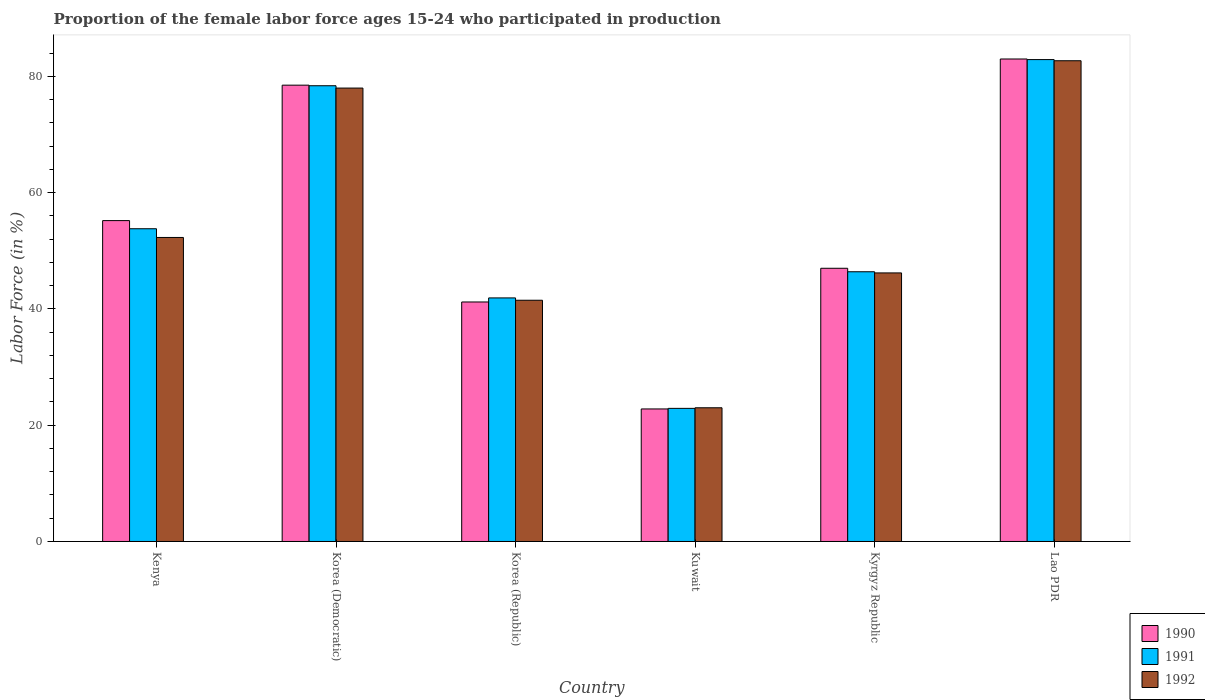How many groups of bars are there?
Keep it short and to the point. 6. How many bars are there on the 2nd tick from the left?
Your response must be concise. 3. How many bars are there on the 3rd tick from the right?
Offer a terse response. 3. What is the label of the 5th group of bars from the left?
Offer a very short reply. Kyrgyz Republic. What is the proportion of the female labor force who participated in production in 1991 in Kyrgyz Republic?
Provide a short and direct response. 46.4. Across all countries, what is the maximum proportion of the female labor force who participated in production in 1991?
Ensure brevity in your answer.  82.9. Across all countries, what is the minimum proportion of the female labor force who participated in production in 1990?
Your response must be concise. 22.8. In which country was the proportion of the female labor force who participated in production in 1991 maximum?
Offer a very short reply. Lao PDR. In which country was the proportion of the female labor force who participated in production in 1990 minimum?
Your answer should be very brief. Kuwait. What is the total proportion of the female labor force who participated in production in 1990 in the graph?
Provide a short and direct response. 327.7. What is the difference between the proportion of the female labor force who participated in production in 1992 in Kenya and that in Kyrgyz Republic?
Ensure brevity in your answer.  6.1. What is the difference between the proportion of the female labor force who participated in production in 1992 in Kyrgyz Republic and the proportion of the female labor force who participated in production in 1990 in Kuwait?
Keep it short and to the point. 23.4. What is the average proportion of the female labor force who participated in production in 1992 per country?
Your answer should be compact. 53.95. What is the difference between the proportion of the female labor force who participated in production of/in 1992 and proportion of the female labor force who participated in production of/in 1990 in Korea (Republic)?
Provide a short and direct response. 0.3. What is the ratio of the proportion of the female labor force who participated in production in 1991 in Kuwait to that in Lao PDR?
Offer a very short reply. 0.28. Is the proportion of the female labor force who participated in production in 1991 in Kenya less than that in Kuwait?
Your response must be concise. No. What is the difference between the highest and the second highest proportion of the female labor force who participated in production in 1992?
Ensure brevity in your answer.  30.4. What is the difference between the highest and the lowest proportion of the female labor force who participated in production in 1991?
Your answer should be compact. 60. Is the sum of the proportion of the female labor force who participated in production in 1992 in Korea (Republic) and Kuwait greater than the maximum proportion of the female labor force who participated in production in 1991 across all countries?
Your answer should be compact. No. What does the 1st bar from the left in Kenya represents?
Give a very brief answer. 1990. Is it the case that in every country, the sum of the proportion of the female labor force who participated in production in 1992 and proportion of the female labor force who participated in production in 1990 is greater than the proportion of the female labor force who participated in production in 1991?
Give a very brief answer. Yes. Does the graph contain any zero values?
Provide a short and direct response. No. Does the graph contain grids?
Offer a very short reply. No. Where does the legend appear in the graph?
Offer a terse response. Bottom right. What is the title of the graph?
Keep it short and to the point. Proportion of the female labor force ages 15-24 who participated in production. What is the label or title of the X-axis?
Make the answer very short. Country. What is the label or title of the Y-axis?
Ensure brevity in your answer.  Labor Force (in %). What is the Labor Force (in %) in 1990 in Kenya?
Your response must be concise. 55.2. What is the Labor Force (in %) in 1991 in Kenya?
Your answer should be very brief. 53.8. What is the Labor Force (in %) in 1992 in Kenya?
Your answer should be very brief. 52.3. What is the Labor Force (in %) in 1990 in Korea (Democratic)?
Your response must be concise. 78.5. What is the Labor Force (in %) in 1991 in Korea (Democratic)?
Offer a very short reply. 78.4. What is the Labor Force (in %) in 1992 in Korea (Democratic)?
Make the answer very short. 78. What is the Labor Force (in %) in 1990 in Korea (Republic)?
Give a very brief answer. 41.2. What is the Labor Force (in %) of 1991 in Korea (Republic)?
Offer a very short reply. 41.9. What is the Labor Force (in %) in 1992 in Korea (Republic)?
Ensure brevity in your answer.  41.5. What is the Labor Force (in %) in 1990 in Kuwait?
Give a very brief answer. 22.8. What is the Labor Force (in %) in 1991 in Kuwait?
Ensure brevity in your answer.  22.9. What is the Labor Force (in %) in 1990 in Kyrgyz Republic?
Your answer should be compact. 47. What is the Labor Force (in %) of 1991 in Kyrgyz Republic?
Provide a succinct answer. 46.4. What is the Labor Force (in %) in 1992 in Kyrgyz Republic?
Ensure brevity in your answer.  46.2. What is the Labor Force (in %) in 1991 in Lao PDR?
Your answer should be compact. 82.9. What is the Labor Force (in %) of 1992 in Lao PDR?
Offer a very short reply. 82.7. Across all countries, what is the maximum Labor Force (in %) of 1991?
Ensure brevity in your answer.  82.9. Across all countries, what is the maximum Labor Force (in %) in 1992?
Make the answer very short. 82.7. Across all countries, what is the minimum Labor Force (in %) in 1990?
Give a very brief answer. 22.8. Across all countries, what is the minimum Labor Force (in %) of 1991?
Ensure brevity in your answer.  22.9. Across all countries, what is the minimum Labor Force (in %) in 1992?
Keep it short and to the point. 23. What is the total Labor Force (in %) of 1990 in the graph?
Offer a very short reply. 327.7. What is the total Labor Force (in %) in 1991 in the graph?
Your answer should be compact. 326.3. What is the total Labor Force (in %) of 1992 in the graph?
Give a very brief answer. 323.7. What is the difference between the Labor Force (in %) of 1990 in Kenya and that in Korea (Democratic)?
Offer a terse response. -23.3. What is the difference between the Labor Force (in %) of 1991 in Kenya and that in Korea (Democratic)?
Provide a short and direct response. -24.6. What is the difference between the Labor Force (in %) in 1992 in Kenya and that in Korea (Democratic)?
Ensure brevity in your answer.  -25.7. What is the difference between the Labor Force (in %) of 1990 in Kenya and that in Korea (Republic)?
Your answer should be compact. 14. What is the difference between the Labor Force (in %) of 1991 in Kenya and that in Korea (Republic)?
Your answer should be very brief. 11.9. What is the difference between the Labor Force (in %) of 1992 in Kenya and that in Korea (Republic)?
Your answer should be compact. 10.8. What is the difference between the Labor Force (in %) of 1990 in Kenya and that in Kuwait?
Make the answer very short. 32.4. What is the difference between the Labor Force (in %) in 1991 in Kenya and that in Kuwait?
Give a very brief answer. 30.9. What is the difference between the Labor Force (in %) in 1992 in Kenya and that in Kuwait?
Your answer should be very brief. 29.3. What is the difference between the Labor Force (in %) of 1990 in Kenya and that in Kyrgyz Republic?
Give a very brief answer. 8.2. What is the difference between the Labor Force (in %) in 1991 in Kenya and that in Kyrgyz Republic?
Offer a very short reply. 7.4. What is the difference between the Labor Force (in %) of 1990 in Kenya and that in Lao PDR?
Keep it short and to the point. -27.8. What is the difference between the Labor Force (in %) in 1991 in Kenya and that in Lao PDR?
Offer a very short reply. -29.1. What is the difference between the Labor Force (in %) of 1992 in Kenya and that in Lao PDR?
Provide a short and direct response. -30.4. What is the difference between the Labor Force (in %) of 1990 in Korea (Democratic) and that in Korea (Republic)?
Offer a very short reply. 37.3. What is the difference between the Labor Force (in %) in 1991 in Korea (Democratic) and that in Korea (Republic)?
Keep it short and to the point. 36.5. What is the difference between the Labor Force (in %) of 1992 in Korea (Democratic) and that in Korea (Republic)?
Make the answer very short. 36.5. What is the difference between the Labor Force (in %) in 1990 in Korea (Democratic) and that in Kuwait?
Offer a terse response. 55.7. What is the difference between the Labor Force (in %) in 1991 in Korea (Democratic) and that in Kuwait?
Provide a short and direct response. 55.5. What is the difference between the Labor Force (in %) of 1990 in Korea (Democratic) and that in Kyrgyz Republic?
Keep it short and to the point. 31.5. What is the difference between the Labor Force (in %) of 1992 in Korea (Democratic) and that in Kyrgyz Republic?
Your response must be concise. 31.8. What is the difference between the Labor Force (in %) in 1990 in Korea (Republic) and that in Kuwait?
Your answer should be compact. 18.4. What is the difference between the Labor Force (in %) in 1992 in Korea (Republic) and that in Kuwait?
Your answer should be very brief. 18.5. What is the difference between the Labor Force (in %) in 1990 in Korea (Republic) and that in Kyrgyz Republic?
Give a very brief answer. -5.8. What is the difference between the Labor Force (in %) in 1991 in Korea (Republic) and that in Kyrgyz Republic?
Provide a short and direct response. -4.5. What is the difference between the Labor Force (in %) in 1990 in Korea (Republic) and that in Lao PDR?
Offer a very short reply. -41.8. What is the difference between the Labor Force (in %) of 1991 in Korea (Republic) and that in Lao PDR?
Your response must be concise. -41. What is the difference between the Labor Force (in %) of 1992 in Korea (Republic) and that in Lao PDR?
Offer a terse response. -41.2. What is the difference between the Labor Force (in %) of 1990 in Kuwait and that in Kyrgyz Republic?
Give a very brief answer. -24.2. What is the difference between the Labor Force (in %) of 1991 in Kuwait and that in Kyrgyz Republic?
Your response must be concise. -23.5. What is the difference between the Labor Force (in %) of 1992 in Kuwait and that in Kyrgyz Republic?
Give a very brief answer. -23.2. What is the difference between the Labor Force (in %) of 1990 in Kuwait and that in Lao PDR?
Your answer should be compact. -60.2. What is the difference between the Labor Force (in %) of 1991 in Kuwait and that in Lao PDR?
Offer a very short reply. -60. What is the difference between the Labor Force (in %) in 1992 in Kuwait and that in Lao PDR?
Give a very brief answer. -59.7. What is the difference between the Labor Force (in %) of 1990 in Kyrgyz Republic and that in Lao PDR?
Offer a very short reply. -36. What is the difference between the Labor Force (in %) of 1991 in Kyrgyz Republic and that in Lao PDR?
Keep it short and to the point. -36.5. What is the difference between the Labor Force (in %) of 1992 in Kyrgyz Republic and that in Lao PDR?
Offer a terse response. -36.5. What is the difference between the Labor Force (in %) of 1990 in Kenya and the Labor Force (in %) of 1991 in Korea (Democratic)?
Keep it short and to the point. -23.2. What is the difference between the Labor Force (in %) of 1990 in Kenya and the Labor Force (in %) of 1992 in Korea (Democratic)?
Keep it short and to the point. -22.8. What is the difference between the Labor Force (in %) of 1991 in Kenya and the Labor Force (in %) of 1992 in Korea (Democratic)?
Provide a short and direct response. -24.2. What is the difference between the Labor Force (in %) of 1990 in Kenya and the Labor Force (in %) of 1991 in Kuwait?
Your response must be concise. 32.3. What is the difference between the Labor Force (in %) in 1990 in Kenya and the Labor Force (in %) in 1992 in Kuwait?
Make the answer very short. 32.2. What is the difference between the Labor Force (in %) of 1991 in Kenya and the Labor Force (in %) of 1992 in Kuwait?
Offer a terse response. 30.8. What is the difference between the Labor Force (in %) in 1990 in Kenya and the Labor Force (in %) in 1991 in Kyrgyz Republic?
Make the answer very short. 8.8. What is the difference between the Labor Force (in %) of 1990 in Kenya and the Labor Force (in %) of 1992 in Kyrgyz Republic?
Offer a very short reply. 9. What is the difference between the Labor Force (in %) of 1991 in Kenya and the Labor Force (in %) of 1992 in Kyrgyz Republic?
Provide a succinct answer. 7.6. What is the difference between the Labor Force (in %) of 1990 in Kenya and the Labor Force (in %) of 1991 in Lao PDR?
Provide a short and direct response. -27.7. What is the difference between the Labor Force (in %) of 1990 in Kenya and the Labor Force (in %) of 1992 in Lao PDR?
Make the answer very short. -27.5. What is the difference between the Labor Force (in %) of 1991 in Kenya and the Labor Force (in %) of 1992 in Lao PDR?
Provide a short and direct response. -28.9. What is the difference between the Labor Force (in %) of 1990 in Korea (Democratic) and the Labor Force (in %) of 1991 in Korea (Republic)?
Your response must be concise. 36.6. What is the difference between the Labor Force (in %) of 1990 in Korea (Democratic) and the Labor Force (in %) of 1992 in Korea (Republic)?
Make the answer very short. 37. What is the difference between the Labor Force (in %) in 1991 in Korea (Democratic) and the Labor Force (in %) in 1992 in Korea (Republic)?
Your answer should be very brief. 36.9. What is the difference between the Labor Force (in %) of 1990 in Korea (Democratic) and the Labor Force (in %) of 1991 in Kuwait?
Your answer should be compact. 55.6. What is the difference between the Labor Force (in %) in 1990 in Korea (Democratic) and the Labor Force (in %) in 1992 in Kuwait?
Your answer should be compact. 55.5. What is the difference between the Labor Force (in %) of 1991 in Korea (Democratic) and the Labor Force (in %) of 1992 in Kuwait?
Offer a terse response. 55.4. What is the difference between the Labor Force (in %) in 1990 in Korea (Democratic) and the Labor Force (in %) in 1991 in Kyrgyz Republic?
Offer a terse response. 32.1. What is the difference between the Labor Force (in %) in 1990 in Korea (Democratic) and the Labor Force (in %) in 1992 in Kyrgyz Republic?
Your answer should be very brief. 32.3. What is the difference between the Labor Force (in %) in 1991 in Korea (Democratic) and the Labor Force (in %) in 1992 in Kyrgyz Republic?
Your response must be concise. 32.2. What is the difference between the Labor Force (in %) in 1990 in Korea (Democratic) and the Labor Force (in %) in 1991 in Lao PDR?
Offer a very short reply. -4.4. What is the difference between the Labor Force (in %) in 1990 in Korea (Democratic) and the Labor Force (in %) in 1992 in Lao PDR?
Make the answer very short. -4.2. What is the difference between the Labor Force (in %) of 1991 in Korea (Democratic) and the Labor Force (in %) of 1992 in Lao PDR?
Your answer should be very brief. -4.3. What is the difference between the Labor Force (in %) in 1991 in Korea (Republic) and the Labor Force (in %) in 1992 in Kuwait?
Ensure brevity in your answer.  18.9. What is the difference between the Labor Force (in %) of 1991 in Korea (Republic) and the Labor Force (in %) of 1992 in Kyrgyz Republic?
Offer a very short reply. -4.3. What is the difference between the Labor Force (in %) of 1990 in Korea (Republic) and the Labor Force (in %) of 1991 in Lao PDR?
Your answer should be compact. -41.7. What is the difference between the Labor Force (in %) of 1990 in Korea (Republic) and the Labor Force (in %) of 1992 in Lao PDR?
Keep it short and to the point. -41.5. What is the difference between the Labor Force (in %) of 1991 in Korea (Republic) and the Labor Force (in %) of 1992 in Lao PDR?
Ensure brevity in your answer.  -40.8. What is the difference between the Labor Force (in %) in 1990 in Kuwait and the Labor Force (in %) in 1991 in Kyrgyz Republic?
Provide a succinct answer. -23.6. What is the difference between the Labor Force (in %) in 1990 in Kuwait and the Labor Force (in %) in 1992 in Kyrgyz Republic?
Ensure brevity in your answer.  -23.4. What is the difference between the Labor Force (in %) in 1991 in Kuwait and the Labor Force (in %) in 1992 in Kyrgyz Republic?
Ensure brevity in your answer.  -23.3. What is the difference between the Labor Force (in %) of 1990 in Kuwait and the Labor Force (in %) of 1991 in Lao PDR?
Your answer should be compact. -60.1. What is the difference between the Labor Force (in %) of 1990 in Kuwait and the Labor Force (in %) of 1992 in Lao PDR?
Give a very brief answer. -59.9. What is the difference between the Labor Force (in %) of 1991 in Kuwait and the Labor Force (in %) of 1992 in Lao PDR?
Your response must be concise. -59.8. What is the difference between the Labor Force (in %) in 1990 in Kyrgyz Republic and the Labor Force (in %) in 1991 in Lao PDR?
Offer a terse response. -35.9. What is the difference between the Labor Force (in %) of 1990 in Kyrgyz Republic and the Labor Force (in %) of 1992 in Lao PDR?
Keep it short and to the point. -35.7. What is the difference between the Labor Force (in %) of 1991 in Kyrgyz Republic and the Labor Force (in %) of 1992 in Lao PDR?
Make the answer very short. -36.3. What is the average Labor Force (in %) of 1990 per country?
Offer a terse response. 54.62. What is the average Labor Force (in %) of 1991 per country?
Your answer should be very brief. 54.38. What is the average Labor Force (in %) of 1992 per country?
Keep it short and to the point. 53.95. What is the difference between the Labor Force (in %) of 1990 and Labor Force (in %) of 1991 in Kenya?
Ensure brevity in your answer.  1.4. What is the difference between the Labor Force (in %) in 1990 and Labor Force (in %) in 1991 in Korea (Democratic)?
Provide a succinct answer. 0.1. What is the difference between the Labor Force (in %) of 1991 and Labor Force (in %) of 1992 in Korea (Democratic)?
Offer a terse response. 0.4. What is the difference between the Labor Force (in %) in 1990 and Labor Force (in %) in 1991 in Korea (Republic)?
Ensure brevity in your answer.  -0.7. What is the difference between the Labor Force (in %) in 1990 and Labor Force (in %) in 1992 in Korea (Republic)?
Your answer should be compact. -0.3. What is the difference between the Labor Force (in %) in 1990 and Labor Force (in %) in 1991 in Kuwait?
Provide a short and direct response. -0.1. What is the difference between the Labor Force (in %) in 1990 and Labor Force (in %) in 1992 in Kuwait?
Offer a terse response. -0.2. What is the difference between the Labor Force (in %) in 1990 and Labor Force (in %) in 1991 in Kyrgyz Republic?
Your answer should be compact. 0.6. What is the difference between the Labor Force (in %) of 1990 and Labor Force (in %) of 1992 in Kyrgyz Republic?
Provide a succinct answer. 0.8. What is the difference between the Labor Force (in %) of 1990 and Labor Force (in %) of 1992 in Lao PDR?
Offer a terse response. 0.3. What is the difference between the Labor Force (in %) in 1991 and Labor Force (in %) in 1992 in Lao PDR?
Your answer should be very brief. 0.2. What is the ratio of the Labor Force (in %) of 1990 in Kenya to that in Korea (Democratic)?
Keep it short and to the point. 0.7. What is the ratio of the Labor Force (in %) in 1991 in Kenya to that in Korea (Democratic)?
Provide a short and direct response. 0.69. What is the ratio of the Labor Force (in %) of 1992 in Kenya to that in Korea (Democratic)?
Offer a very short reply. 0.67. What is the ratio of the Labor Force (in %) of 1990 in Kenya to that in Korea (Republic)?
Offer a terse response. 1.34. What is the ratio of the Labor Force (in %) in 1991 in Kenya to that in Korea (Republic)?
Provide a short and direct response. 1.28. What is the ratio of the Labor Force (in %) of 1992 in Kenya to that in Korea (Republic)?
Offer a terse response. 1.26. What is the ratio of the Labor Force (in %) of 1990 in Kenya to that in Kuwait?
Provide a succinct answer. 2.42. What is the ratio of the Labor Force (in %) in 1991 in Kenya to that in Kuwait?
Make the answer very short. 2.35. What is the ratio of the Labor Force (in %) of 1992 in Kenya to that in Kuwait?
Your answer should be very brief. 2.27. What is the ratio of the Labor Force (in %) in 1990 in Kenya to that in Kyrgyz Republic?
Ensure brevity in your answer.  1.17. What is the ratio of the Labor Force (in %) of 1991 in Kenya to that in Kyrgyz Republic?
Your response must be concise. 1.16. What is the ratio of the Labor Force (in %) in 1992 in Kenya to that in Kyrgyz Republic?
Your answer should be compact. 1.13. What is the ratio of the Labor Force (in %) in 1990 in Kenya to that in Lao PDR?
Offer a very short reply. 0.67. What is the ratio of the Labor Force (in %) in 1991 in Kenya to that in Lao PDR?
Your response must be concise. 0.65. What is the ratio of the Labor Force (in %) in 1992 in Kenya to that in Lao PDR?
Your response must be concise. 0.63. What is the ratio of the Labor Force (in %) of 1990 in Korea (Democratic) to that in Korea (Republic)?
Provide a short and direct response. 1.91. What is the ratio of the Labor Force (in %) of 1991 in Korea (Democratic) to that in Korea (Republic)?
Your answer should be compact. 1.87. What is the ratio of the Labor Force (in %) in 1992 in Korea (Democratic) to that in Korea (Republic)?
Your answer should be compact. 1.88. What is the ratio of the Labor Force (in %) of 1990 in Korea (Democratic) to that in Kuwait?
Provide a short and direct response. 3.44. What is the ratio of the Labor Force (in %) in 1991 in Korea (Democratic) to that in Kuwait?
Your answer should be compact. 3.42. What is the ratio of the Labor Force (in %) of 1992 in Korea (Democratic) to that in Kuwait?
Give a very brief answer. 3.39. What is the ratio of the Labor Force (in %) in 1990 in Korea (Democratic) to that in Kyrgyz Republic?
Ensure brevity in your answer.  1.67. What is the ratio of the Labor Force (in %) of 1991 in Korea (Democratic) to that in Kyrgyz Republic?
Offer a very short reply. 1.69. What is the ratio of the Labor Force (in %) of 1992 in Korea (Democratic) to that in Kyrgyz Republic?
Your answer should be compact. 1.69. What is the ratio of the Labor Force (in %) in 1990 in Korea (Democratic) to that in Lao PDR?
Give a very brief answer. 0.95. What is the ratio of the Labor Force (in %) of 1991 in Korea (Democratic) to that in Lao PDR?
Provide a succinct answer. 0.95. What is the ratio of the Labor Force (in %) of 1992 in Korea (Democratic) to that in Lao PDR?
Keep it short and to the point. 0.94. What is the ratio of the Labor Force (in %) in 1990 in Korea (Republic) to that in Kuwait?
Provide a succinct answer. 1.81. What is the ratio of the Labor Force (in %) of 1991 in Korea (Republic) to that in Kuwait?
Keep it short and to the point. 1.83. What is the ratio of the Labor Force (in %) in 1992 in Korea (Republic) to that in Kuwait?
Your answer should be very brief. 1.8. What is the ratio of the Labor Force (in %) in 1990 in Korea (Republic) to that in Kyrgyz Republic?
Your answer should be very brief. 0.88. What is the ratio of the Labor Force (in %) in 1991 in Korea (Republic) to that in Kyrgyz Republic?
Your answer should be very brief. 0.9. What is the ratio of the Labor Force (in %) of 1992 in Korea (Republic) to that in Kyrgyz Republic?
Provide a succinct answer. 0.9. What is the ratio of the Labor Force (in %) in 1990 in Korea (Republic) to that in Lao PDR?
Keep it short and to the point. 0.5. What is the ratio of the Labor Force (in %) in 1991 in Korea (Republic) to that in Lao PDR?
Provide a succinct answer. 0.51. What is the ratio of the Labor Force (in %) in 1992 in Korea (Republic) to that in Lao PDR?
Keep it short and to the point. 0.5. What is the ratio of the Labor Force (in %) in 1990 in Kuwait to that in Kyrgyz Republic?
Offer a very short reply. 0.49. What is the ratio of the Labor Force (in %) in 1991 in Kuwait to that in Kyrgyz Republic?
Ensure brevity in your answer.  0.49. What is the ratio of the Labor Force (in %) of 1992 in Kuwait to that in Kyrgyz Republic?
Ensure brevity in your answer.  0.5. What is the ratio of the Labor Force (in %) of 1990 in Kuwait to that in Lao PDR?
Your answer should be compact. 0.27. What is the ratio of the Labor Force (in %) of 1991 in Kuwait to that in Lao PDR?
Provide a short and direct response. 0.28. What is the ratio of the Labor Force (in %) of 1992 in Kuwait to that in Lao PDR?
Make the answer very short. 0.28. What is the ratio of the Labor Force (in %) in 1990 in Kyrgyz Republic to that in Lao PDR?
Keep it short and to the point. 0.57. What is the ratio of the Labor Force (in %) of 1991 in Kyrgyz Republic to that in Lao PDR?
Provide a short and direct response. 0.56. What is the ratio of the Labor Force (in %) in 1992 in Kyrgyz Republic to that in Lao PDR?
Your answer should be compact. 0.56. What is the difference between the highest and the second highest Labor Force (in %) in 1990?
Your response must be concise. 4.5. What is the difference between the highest and the second highest Labor Force (in %) of 1991?
Your answer should be compact. 4.5. What is the difference between the highest and the lowest Labor Force (in %) in 1990?
Offer a very short reply. 60.2. What is the difference between the highest and the lowest Labor Force (in %) of 1992?
Provide a succinct answer. 59.7. 